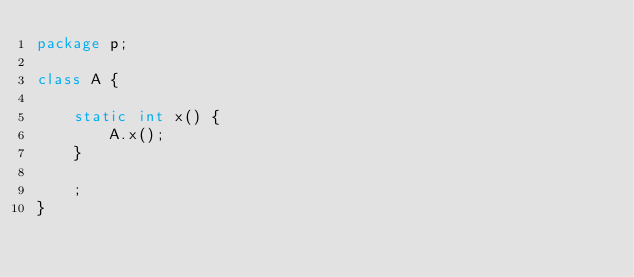<code> <loc_0><loc_0><loc_500><loc_500><_Java_>package p;

class A {

    static int x() {
        A.x();
    }

    ;
}
</code> 